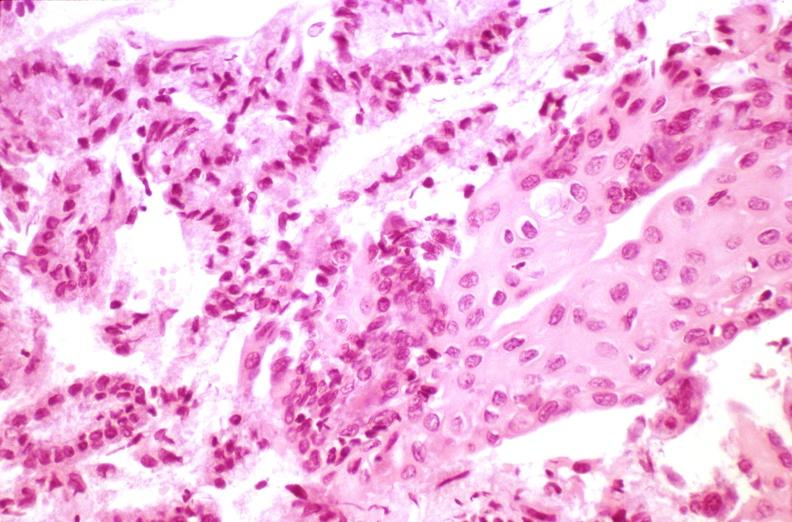s mucoepidermoid carcinoma present?
Answer the question using a single word or phrase. No 